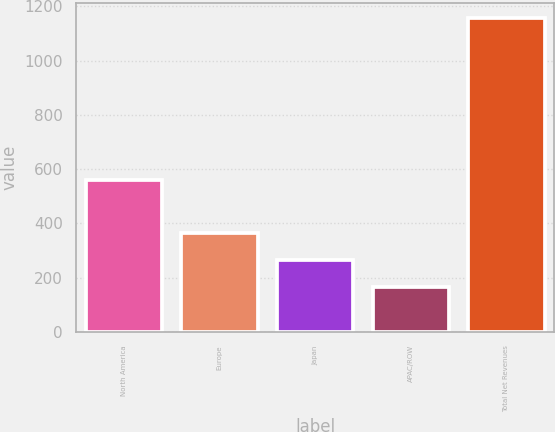Convert chart to OTSL. <chart><loc_0><loc_0><loc_500><loc_500><bar_chart><fcel>North America<fcel>Europe<fcel>Japan<fcel>APAC/ROW<fcel>Total Net Revenues<nl><fcel>559<fcel>364.24<fcel>265.27<fcel>166.3<fcel>1156<nl></chart> 